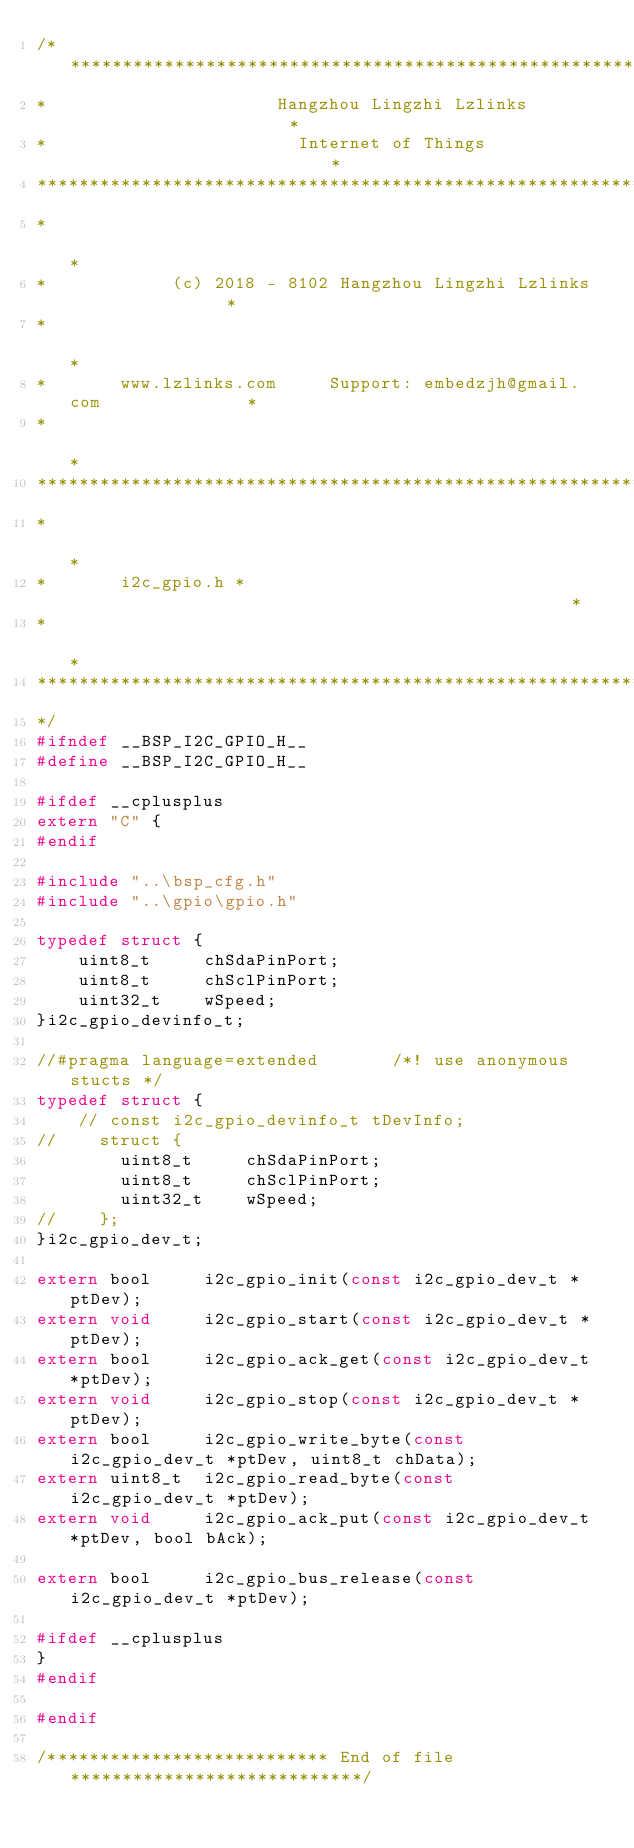<code> <loc_0><loc_0><loc_500><loc_500><_C_>/*********************************************************************
*                      Hangzhou Lingzhi Lzlinks                      *
*                        Internet of Things                          *
**********************************************************************
*                                                                    *
*            (c) 2018 - 8102 Hangzhou Lingzhi Lzlinks                *
*                                                                    *
*       www.lzlinks.com     Support: embedzjh@gmail.com              *
*                                                                    *
**********************************************************************
*                                                                    *
*       i2c_gpio.h *                                                 *
*                                                                    *
**********************************************************************
*/
#ifndef __BSP_I2C_GPIO_H__
#define __BSP_I2C_GPIO_H__

#ifdef __cplusplus
extern "C" {
#endif

#include "..\bsp_cfg.h"
#include "..\gpio\gpio.h"

typedef struct {
    uint8_t     chSdaPinPort;
    uint8_t     chSclPinPort;
    uint32_t    wSpeed;
}i2c_gpio_devinfo_t;

//#pragma language=extended       /*! use anonymous stucts */
typedef struct {
    // const i2c_gpio_devinfo_t tDevInfo;
//    struct {
        uint8_t     chSdaPinPort;
        uint8_t     chSclPinPort;
        uint32_t    wSpeed;
//    };
}i2c_gpio_dev_t;

extern bool     i2c_gpio_init(const i2c_gpio_dev_t *ptDev);
extern void     i2c_gpio_start(const i2c_gpio_dev_t *ptDev);
extern bool     i2c_gpio_ack_get(const i2c_gpio_dev_t *ptDev);
extern void     i2c_gpio_stop(const i2c_gpio_dev_t *ptDev);
extern bool     i2c_gpio_write_byte(const i2c_gpio_dev_t *ptDev, uint8_t chData);
extern uint8_t  i2c_gpio_read_byte(const i2c_gpio_dev_t *ptDev);
extern void     i2c_gpio_ack_put(const i2c_gpio_dev_t *ptDev, bool bAck);

extern bool     i2c_gpio_bus_release(const i2c_gpio_dev_t *ptDev);

#ifdef __cplusplus
}
#endif

#endif

/*************************** End of file ****************************/
</code> 